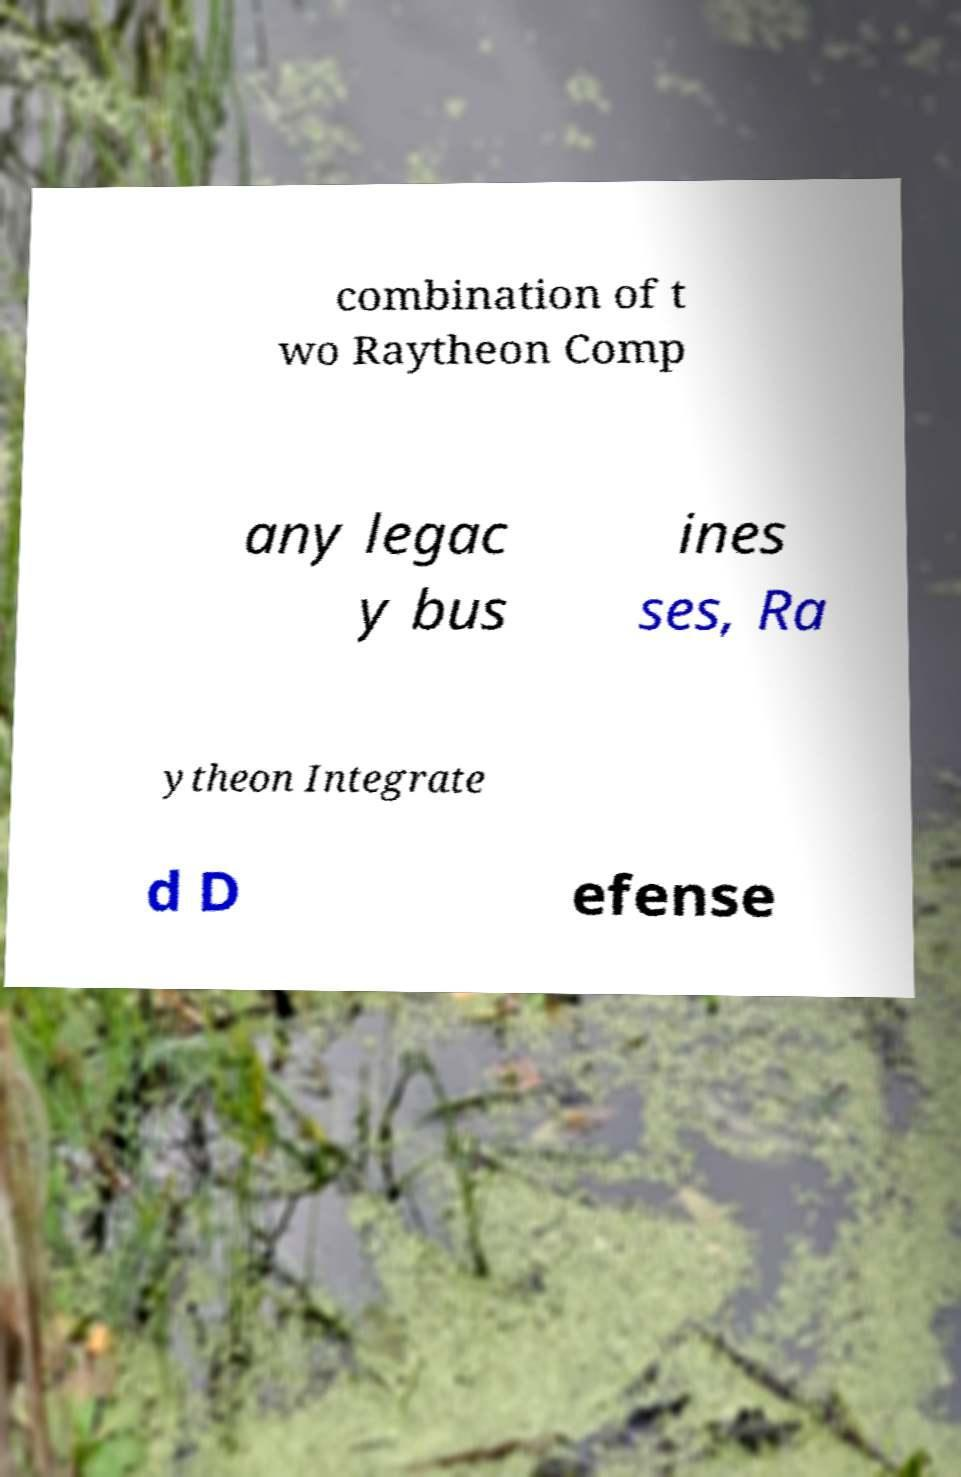Please identify and transcribe the text found in this image. combination of t wo Raytheon Comp any legac y bus ines ses, Ra ytheon Integrate d D efense 